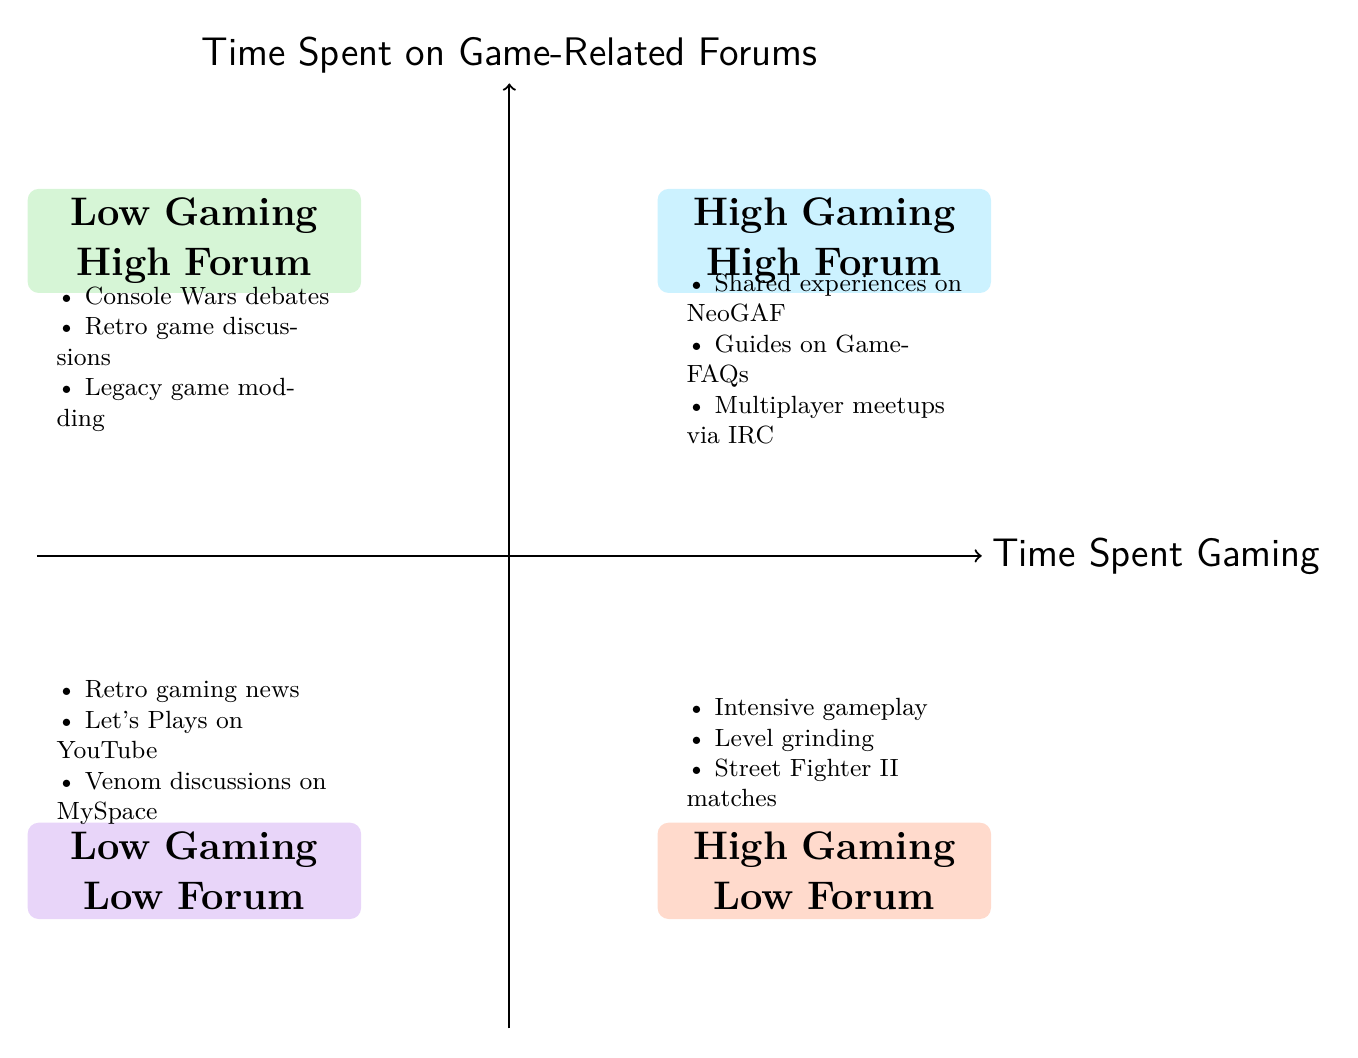What is the category of Quadrant 2? Quadrant 2 is located in the top right of the diagram, indicating a combination of high gaming time and high forum time. The label for Quadrant 2 is "High Gaming Time, High Forum Time."
Answer: High Gaming Time, High Forum Time How many examples are listed in Quadrant 3? Quadrant 3 is identified by two criteria: low gaming time and high forum time. In the diagram, there are exactly three examples provided for this quadrant.
Answer: 3 Which quadrant includes "Let's Plays of old titles on YouTube"? The example "Let's Plays of old titles on YouTube" is shown in Quadrant 4, which features low gaming time and low forum time. The label for this quadrant highlights the limited engagement in both gaming and forums.
Answer: Quadrant 4 What is the relationship between Quadrant 1 and Quadrant 3? Quadrant 1 (High Gaming Time, Low Forum Time) focuses on active gameplay engagement, while Quadrant 3 (Low Gaming Time, High Forum Time) emphasizes forum participation instead of gameplay. Their relationship highlights contrasting engagement in gaming versus forums.
Answer: Contrasting engagement What type of discussions are found in Quadrant 3? Quadrant 3 is characterized by high forum activity with low gaming time. The examples include debates on console wars and discussions about retro game collections. Therefore, the discussions are primarily analytical or community-focused.
Answer: Debates on Console Wars, Retro game discussions Which quadrant is represented by the example "Intensive gameplay sessions"? The example "Intensive gameplay sessions" is placed in Quadrant 4, indicating a scenario where gamers spend a lot of time playing but do not engage significantly on forums.
Answer: Quadrant 3 What is the main focus of Quadrant 2? Quadrant 2 highlights a strong overlap between gaming activities and community engagement on forums. It represents gamers who not only play extensively but also participate in discussions, share strategies, or arrange meetups.
Answer: Strong overlap between gaming activities and community engagement Which emoji is assigned to Quadrant 1? In Quadrant 1, the emoji assigned is "👾", which represents a gaming theme, emphasizing the focus on gaming activities in that quadrant.
Answer: 👾 